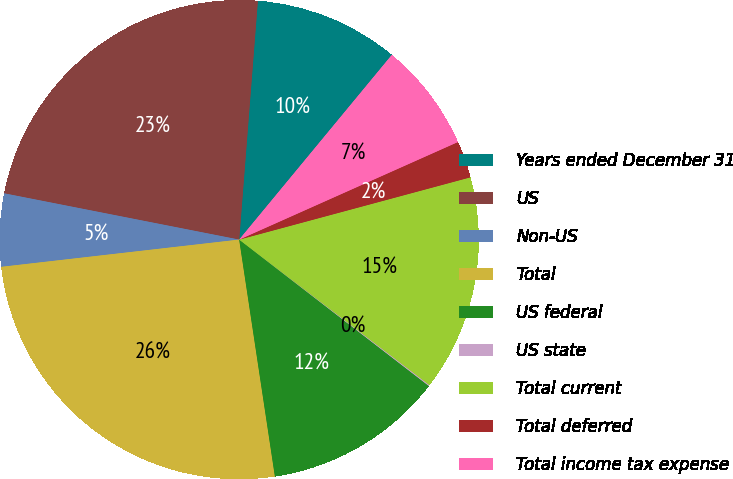Convert chart. <chart><loc_0><loc_0><loc_500><loc_500><pie_chart><fcel>Years ended December 31<fcel>US<fcel>Non-US<fcel>Total<fcel>US federal<fcel>US state<fcel>Total current<fcel>Total deferred<fcel>Total income tax expense<nl><fcel>9.75%<fcel>23.15%<fcel>4.91%<fcel>25.57%<fcel>12.16%<fcel>0.07%<fcel>14.58%<fcel>2.49%<fcel>7.33%<nl></chart> 